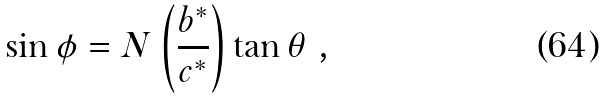Convert formula to latex. <formula><loc_0><loc_0><loc_500><loc_500>\sin \phi = N \left ( \frac { b ^ { * } } { c ^ { * } } \right ) \tan \theta \ ,</formula> 